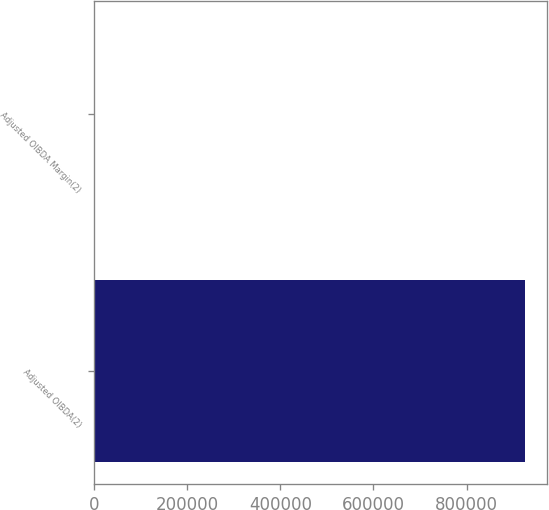<chart> <loc_0><loc_0><loc_500><loc_500><bar_chart><fcel>Adjusted OIBDA(2)<fcel>Adjusted OIBDA Margin(2)<nl><fcel>925797<fcel>29.7<nl></chart> 